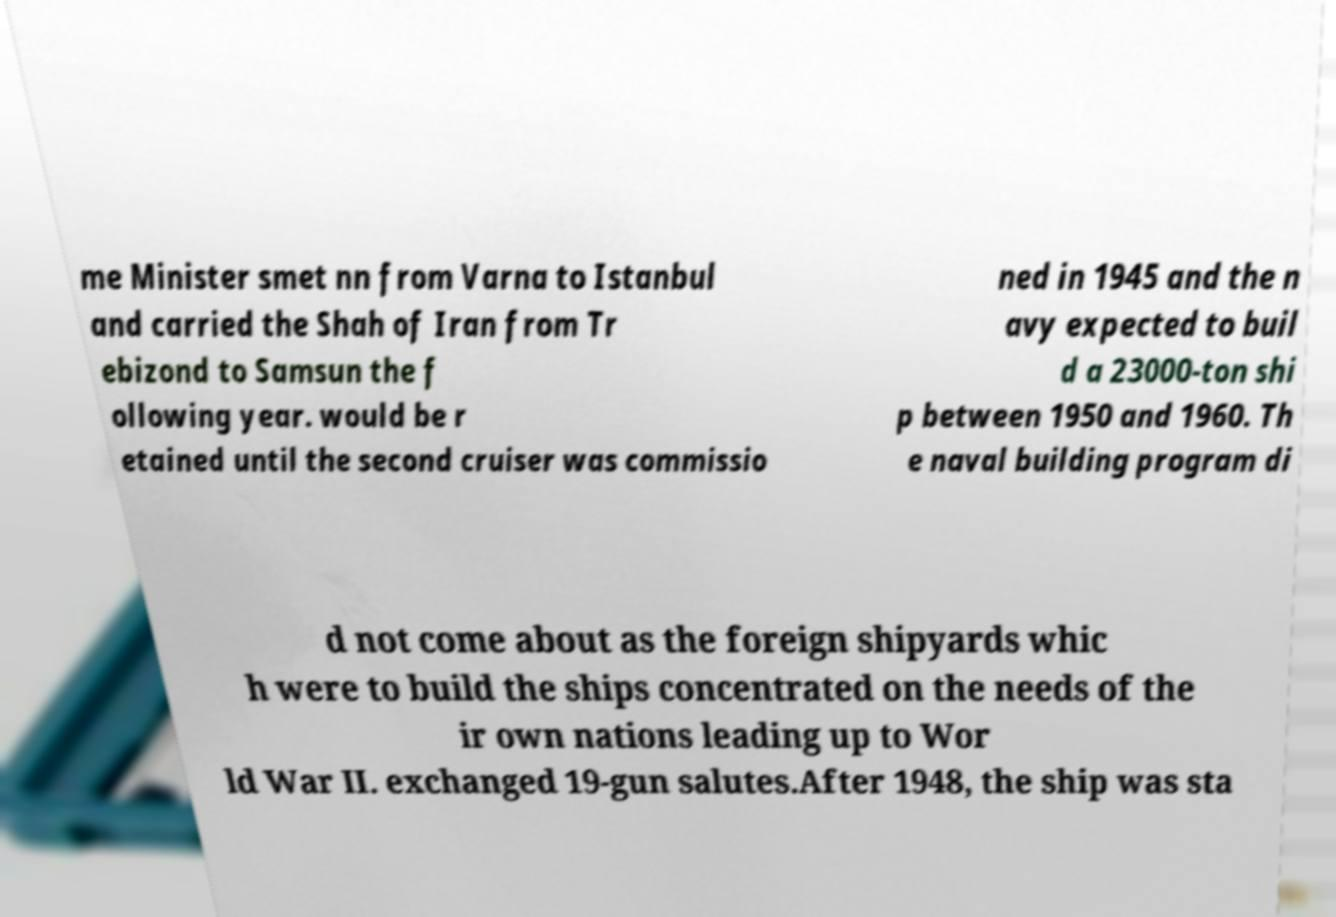For documentation purposes, I need the text within this image transcribed. Could you provide that? me Minister smet nn from Varna to Istanbul and carried the Shah of Iran from Tr ebizond to Samsun the f ollowing year. would be r etained until the second cruiser was commissio ned in 1945 and the n avy expected to buil d a 23000-ton shi p between 1950 and 1960. Th e naval building program di d not come about as the foreign shipyards whic h were to build the ships concentrated on the needs of the ir own nations leading up to Wor ld War II. exchanged 19-gun salutes.After 1948, the ship was sta 